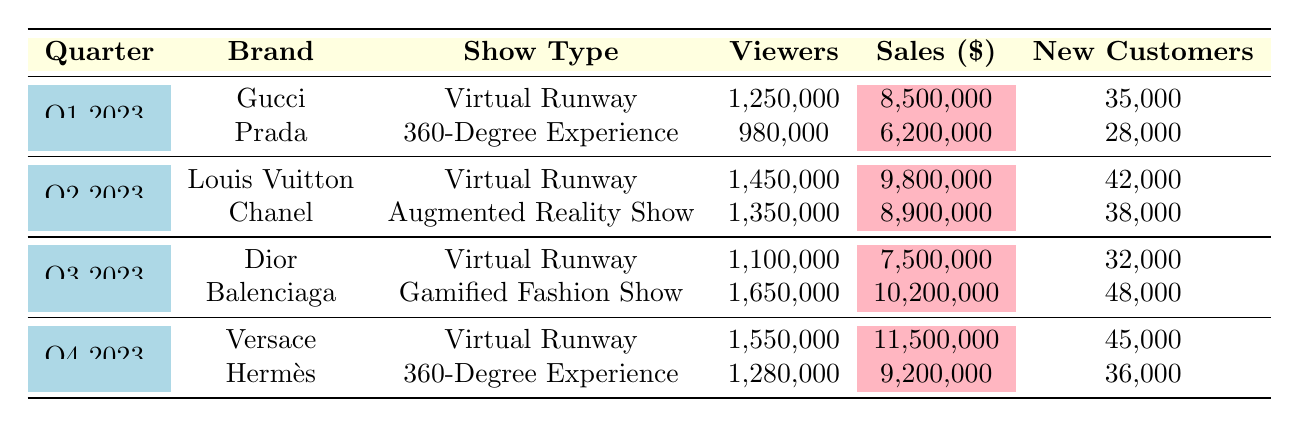What brand had the highest viewer count in Q3 2023? By looking at the rows for Q3 2023, we can see Dior with 1,100,000 viewers and Balenciaga with 1,650,000 viewers. Balenciaga has the highest count.
Answer: Balenciaga What is the total product sales for Q4 2023? In Q4 2023, Versace had sales of 11,500,000 and Hermès had sales of 9,200,000. To find the total, we add these two amounts: 11,500,000 + 9,200,000 = 20,700,000.
Answer: 20,700,000 Which show type had the highest average view time? We compare the Average View Time for each show type. 28 minutes for Balenciaga, 25 minutes for Louis Vuitton, followed by Versace with 24 minutes. Thus, the highest average view time is from Balenciaga.
Answer: Gamified Fashion Show Did any brand have more than 1,200,000 viewers in Q1 2023? Referring to Q1 2023, Gucci had 1,250,000 viewers while Prada had 980,000 viewers. Since Gucci is more than 1,200,000, the answer is yes.
Answer: Yes What is the total number of new customers acquired across all brands in Q2 2023? For Q2 2023, Louis Vuitton acquired 42,000 new customers and Chanel acquired 38,000. Adding them gives 42,000 + 38,000 = 80,000 new customers.
Answer: 80,000 